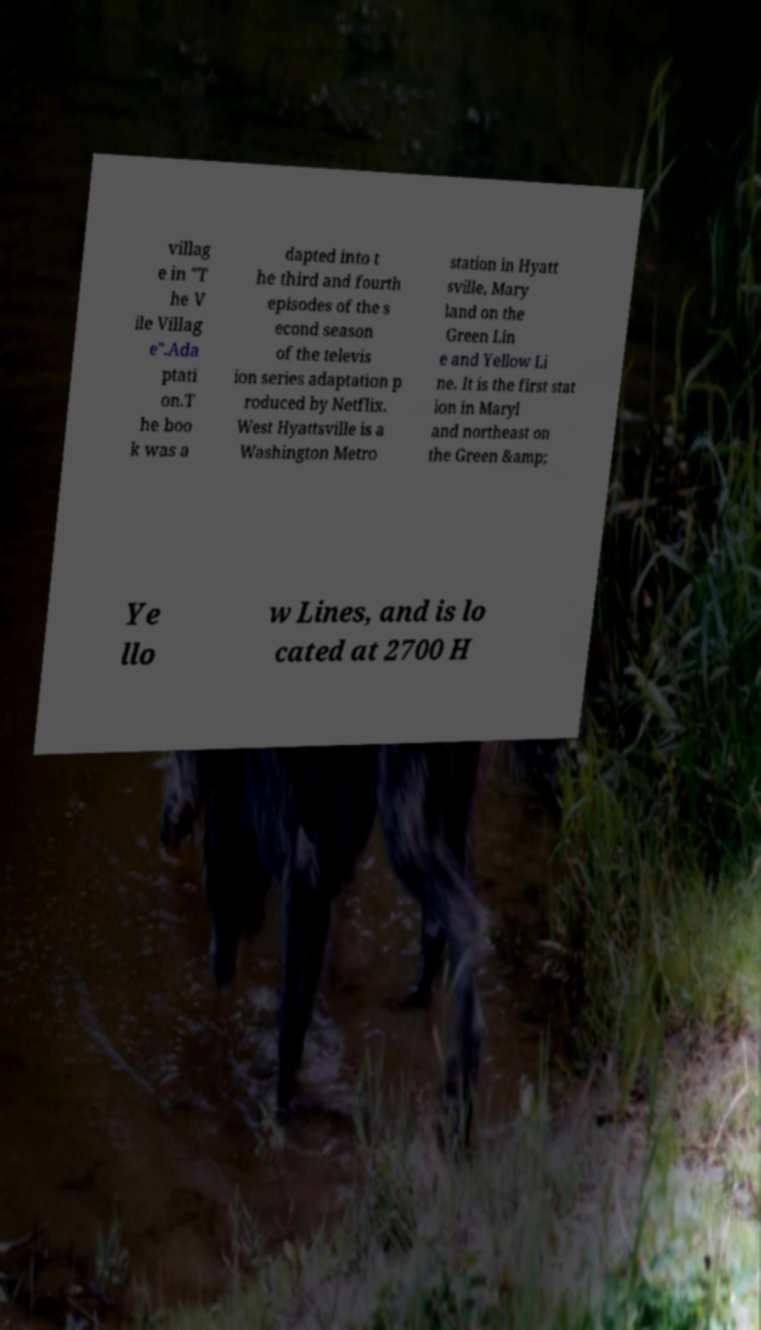Please read and relay the text visible in this image. What does it say? villag e in "T he V ile Villag e".Ada ptati on.T he boo k was a dapted into t he third and fourth episodes of the s econd season of the televis ion series adaptation p roduced by Netflix. West Hyattsville is a Washington Metro station in Hyatt sville, Mary land on the Green Lin e and Yellow Li ne. It is the first stat ion in Maryl and northeast on the Green &amp; Ye llo w Lines, and is lo cated at 2700 H 